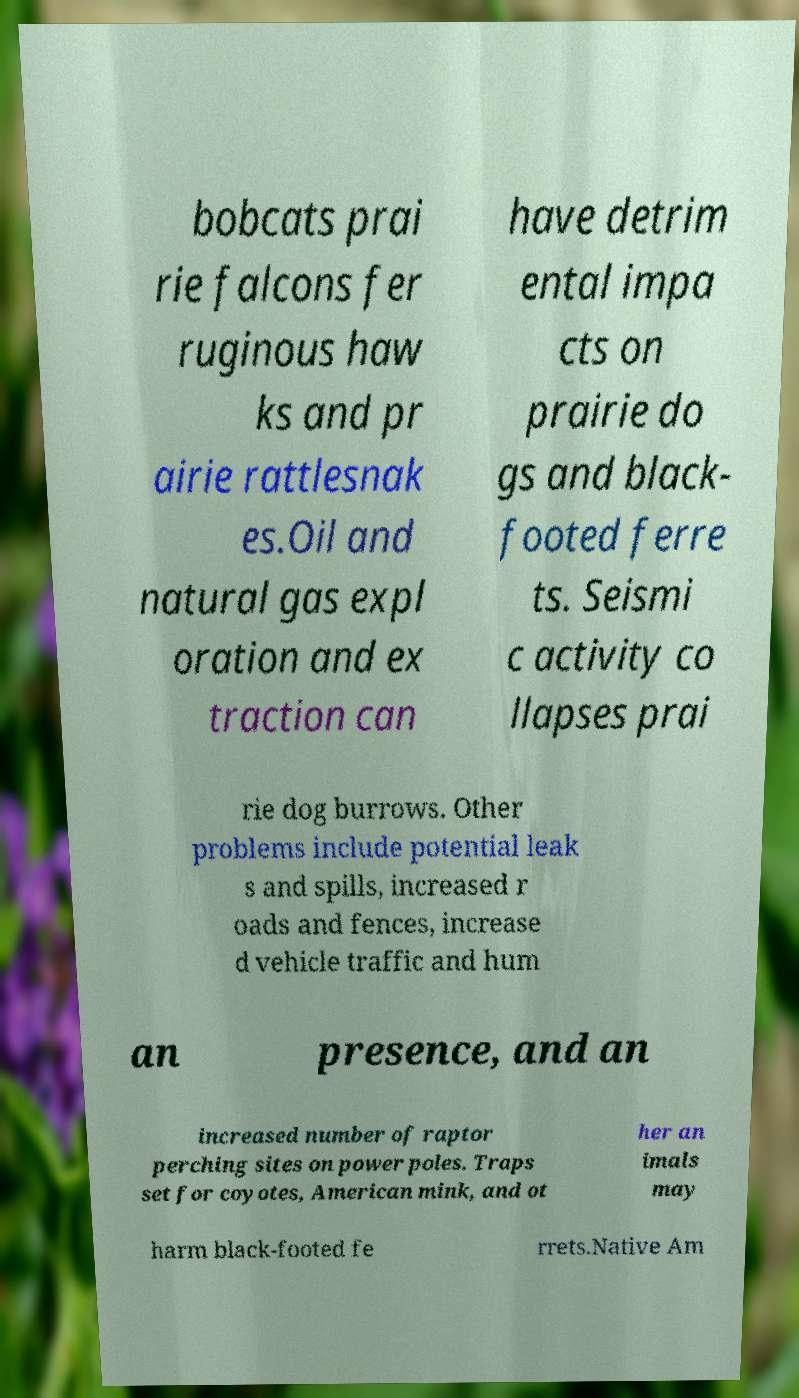Can you read and provide the text displayed in the image?This photo seems to have some interesting text. Can you extract and type it out for me? bobcats prai rie falcons fer ruginous haw ks and pr airie rattlesnak es.Oil and natural gas expl oration and ex traction can have detrim ental impa cts on prairie do gs and black- footed ferre ts. Seismi c activity co llapses prai rie dog burrows. Other problems include potential leak s and spills, increased r oads and fences, increase d vehicle traffic and hum an presence, and an increased number of raptor perching sites on power poles. Traps set for coyotes, American mink, and ot her an imals may harm black-footed fe rrets.Native Am 